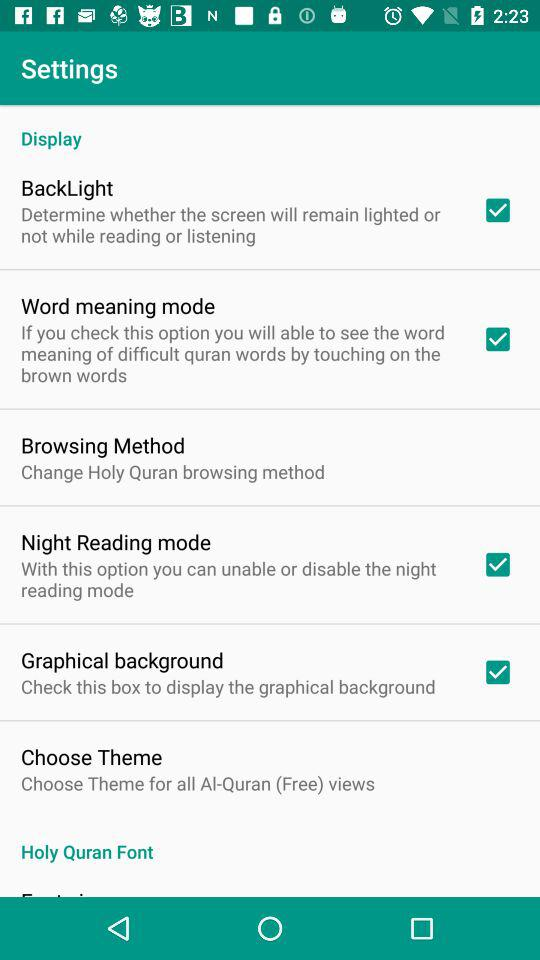Which settings are enabled in this screenshot? In the screenshot, the 'BackLight,' 'Word meaning mode,' 'Night Reading mode,' and 'Graphical background' settings are enabled, as indicated by the checkboxes next to these options being marked. 